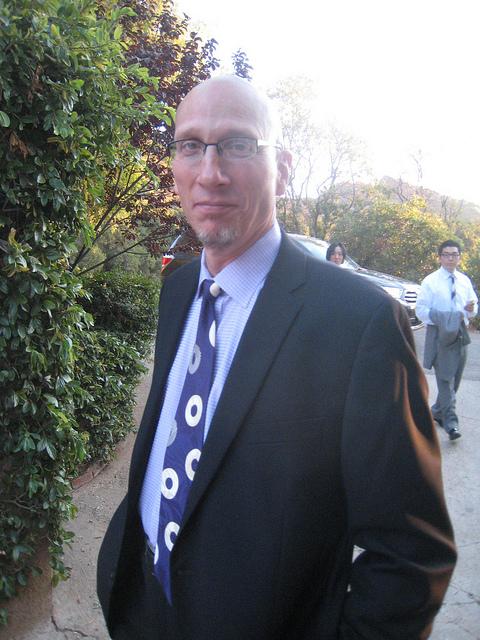What is on the man's tie?
Keep it brief. Circles. Which retail chain has a logo similar to this man's tie?
Write a very short answer. Target. Where does the man have hair?
Give a very brief answer. Chin. 